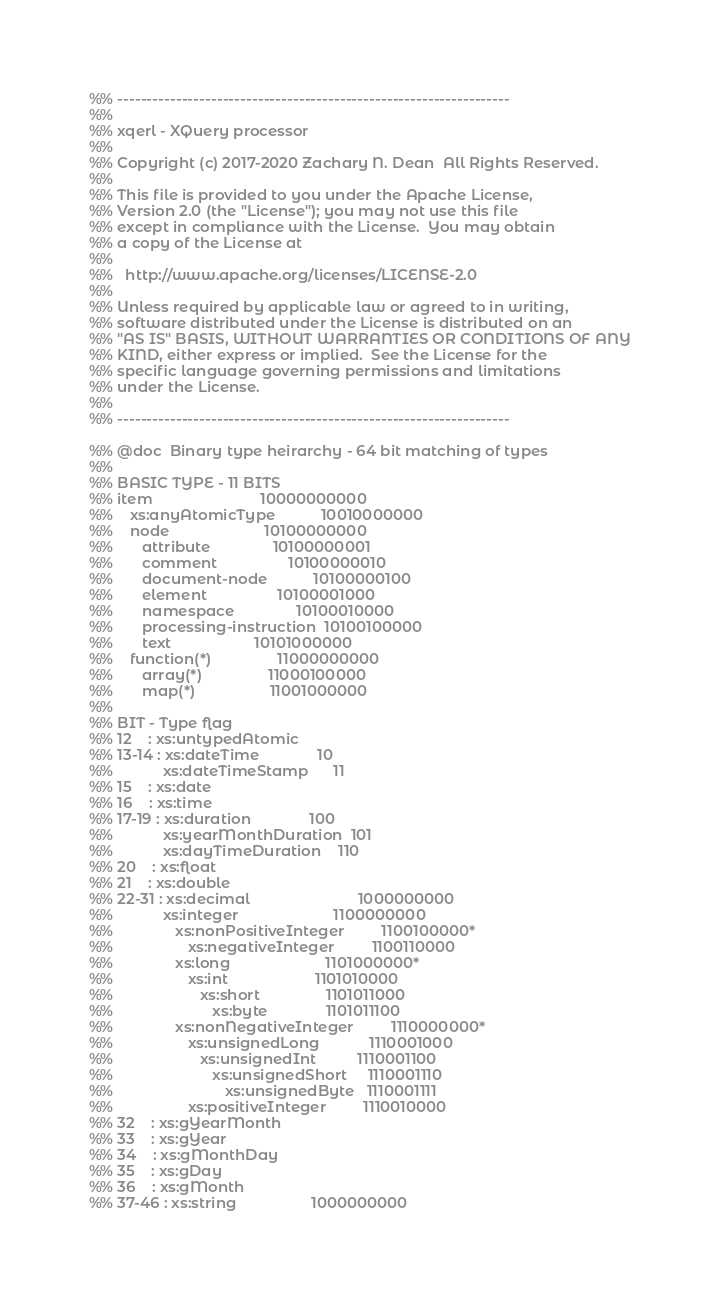Convert code to text. <code><loc_0><loc_0><loc_500><loc_500><_Erlang_>%% -------------------------------------------------------------------
%%
%% xqerl - XQuery processor
%%
%% Copyright (c) 2017-2020 Zachary N. Dean  All Rights Reserved.
%%
%% This file is provided to you under the Apache License,
%% Version 2.0 (the "License"); you may not use this file
%% except in compliance with the License.  You may obtain
%% a copy of the License at
%%
%%   http://www.apache.org/licenses/LICENSE-2.0
%%
%% Unless required by applicable law or agreed to in writing,
%% software distributed under the License is distributed on an
%% "AS IS" BASIS, WITHOUT WARRANTIES OR CONDITIONS OF ANY
%% KIND, either express or implied.  See the License for the
%% specific language governing permissions and limitations
%% under the License.
%%
%% -------------------------------------------------------------------

%% @doc  Binary type heirarchy - 64 bit matching of types
%%
%% BASIC TYPE - 11 BITS
%% item                          10000000000
%%    xs:anyAtomicType           10010000000
%%    node                       10100000000
%%       attribute               10100000001
%%       comment                 10100000010
%%       document-node           10100000100
%%       element                 10100001000
%%       namespace               10100010000
%%       processing-instruction  10100100000
%%       text                    10101000000
%%    function(*)                11000000000
%%       array(*)                11000100000
%%       map(*)                  11001000000
%%
%% BIT - Type flag
%% 12    : xs:untypedAtomic
%% 13-14 : xs:dateTime              10
%%            xs:dateTimeStamp      11
%% 15    : xs:date
%% 16    : xs:time
%% 17-19 : xs:duration              100
%%            xs:yearMonthDuration  101
%%            xs:dayTimeDuration    110
%% 20    : xs:float
%% 21    : xs:double
%% 22-31 : xs:decimal                          1000000000
%%            xs:integer                       1100000000
%%               xs:nonPositiveInteger         1100100000*
%%                  xs:negativeInteger         1100110000
%%               xs:long                       1101000000*
%%                  xs:int                     1101010000
%%                     xs:short                1101011000
%%                        xs:byte              1101011100
%%               xs:nonNegativeInteger         1110000000*
%%                  xs:unsignedLong            1110001000
%%                     xs:unsignedInt          1110001100
%%                        xs:unsignedShort     1110001110
%%                           xs:unsignedByte   1110001111
%%                  xs:positiveInteger         1110010000
%% 32    : xs:gYearMonth
%% 33    : xs:gYear
%% 34    : xs:gMonthDay
%% 35    : xs:gDay
%% 36    : xs:gMonth
%% 37-46 : xs:string                  1000000000</code> 